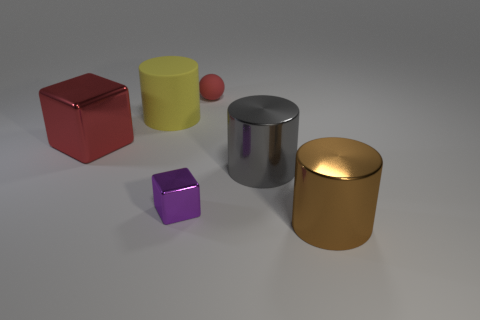Add 1 large brown metal balls. How many objects exist? 7 Subtract all balls. How many objects are left? 5 Add 5 purple things. How many purple things are left? 6 Add 4 shiny blocks. How many shiny blocks exist? 6 Subtract 1 brown cylinders. How many objects are left? 5 Subtract all red metallic blocks. Subtract all large yellow matte objects. How many objects are left? 4 